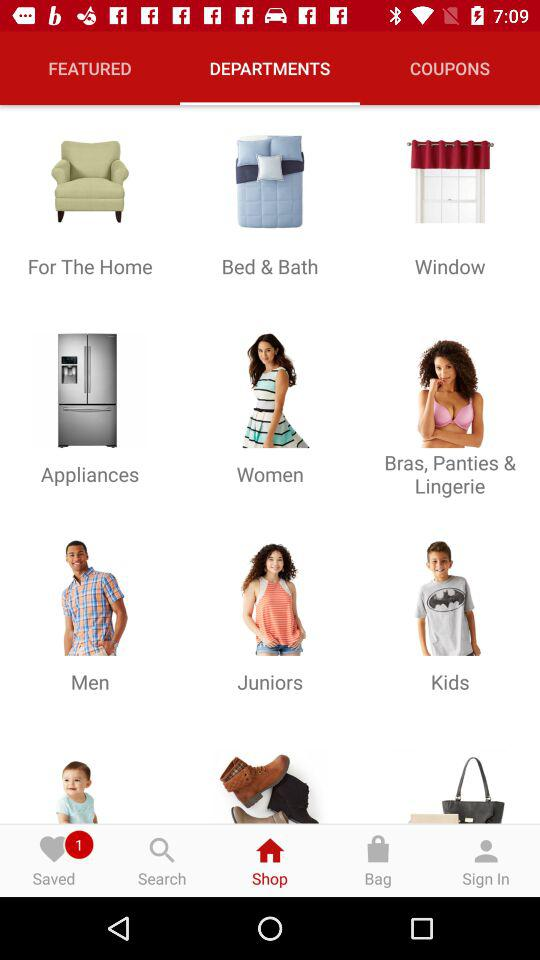How many notifications are pending for the "Saved" option? There is 1 pending notification for the "Saved" option. 